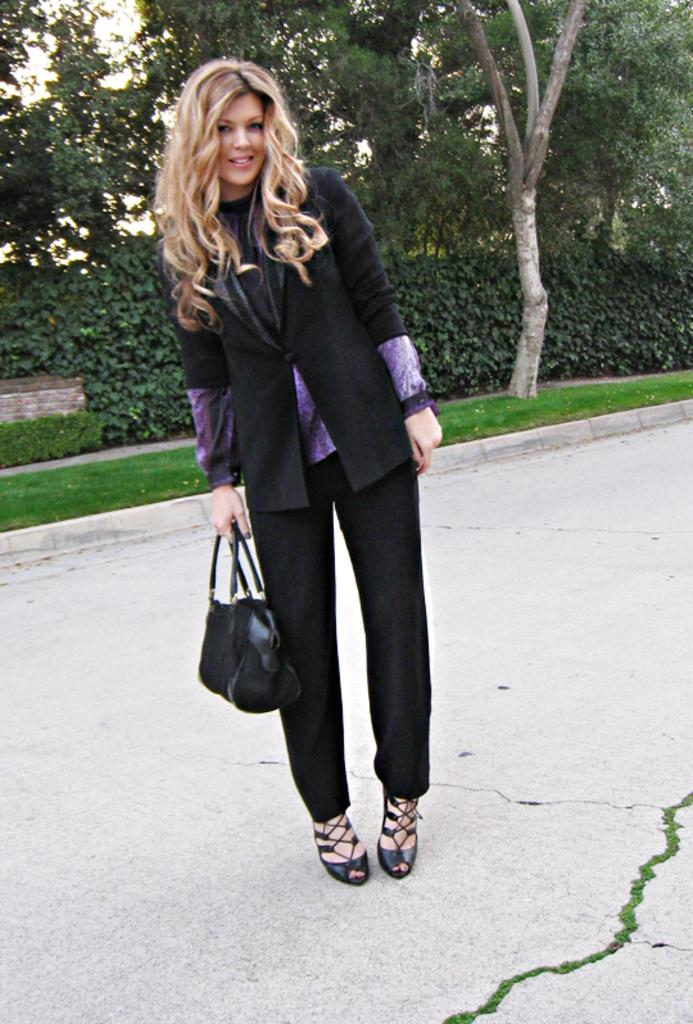Who is present in the image? There is a woman in the image. What is the woman doing in the image? The woman is standing. What object is the woman holding in the image? The woman is holding a handbag. What can be seen in the background of the image? There are trees and grass in the background of the image. What type of yam is the woman eating in the image? There is no yam present in the image, and the woman is not eating anything. 